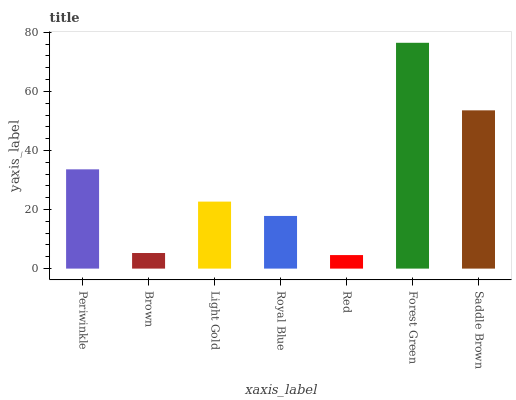Is Red the minimum?
Answer yes or no. Yes. Is Forest Green the maximum?
Answer yes or no. Yes. Is Brown the minimum?
Answer yes or no. No. Is Brown the maximum?
Answer yes or no. No. Is Periwinkle greater than Brown?
Answer yes or no. Yes. Is Brown less than Periwinkle?
Answer yes or no. Yes. Is Brown greater than Periwinkle?
Answer yes or no. No. Is Periwinkle less than Brown?
Answer yes or no. No. Is Light Gold the high median?
Answer yes or no. Yes. Is Light Gold the low median?
Answer yes or no. Yes. Is Royal Blue the high median?
Answer yes or no. No. Is Royal Blue the low median?
Answer yes or no. No. 